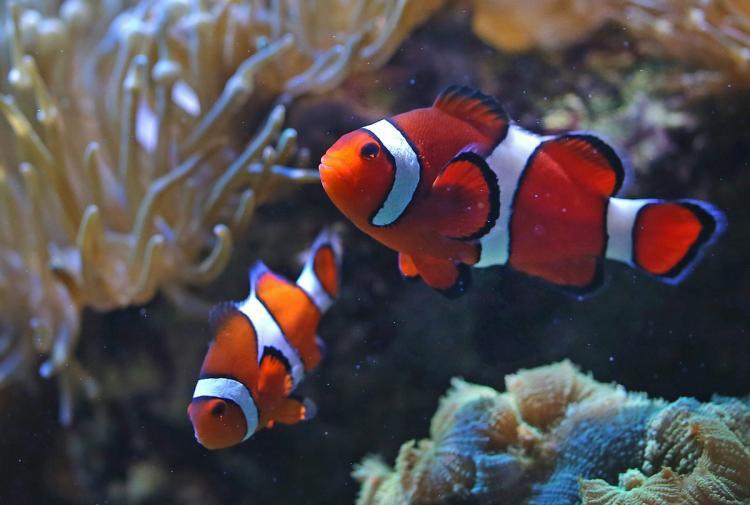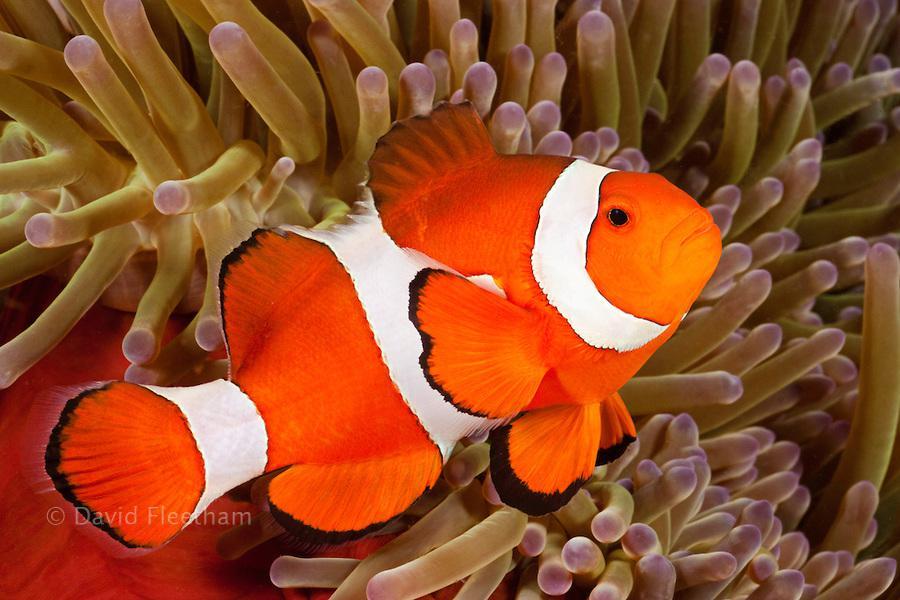The first image is the image on the left, the second image is the image on the right. Analyze the images presented: Is the assertion "There is only one clownfish on the right image" valid? Answer yes or no. Yes. The first image is the image on the left, the second image is the image on the right. Evaluate the accuracy of this statement regarding the images: "There are three fish". Is it true? Answer yes or no. Yes. 